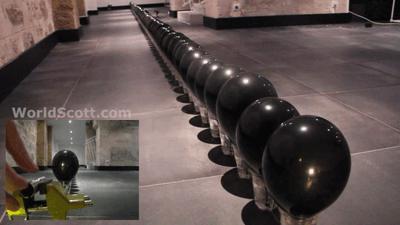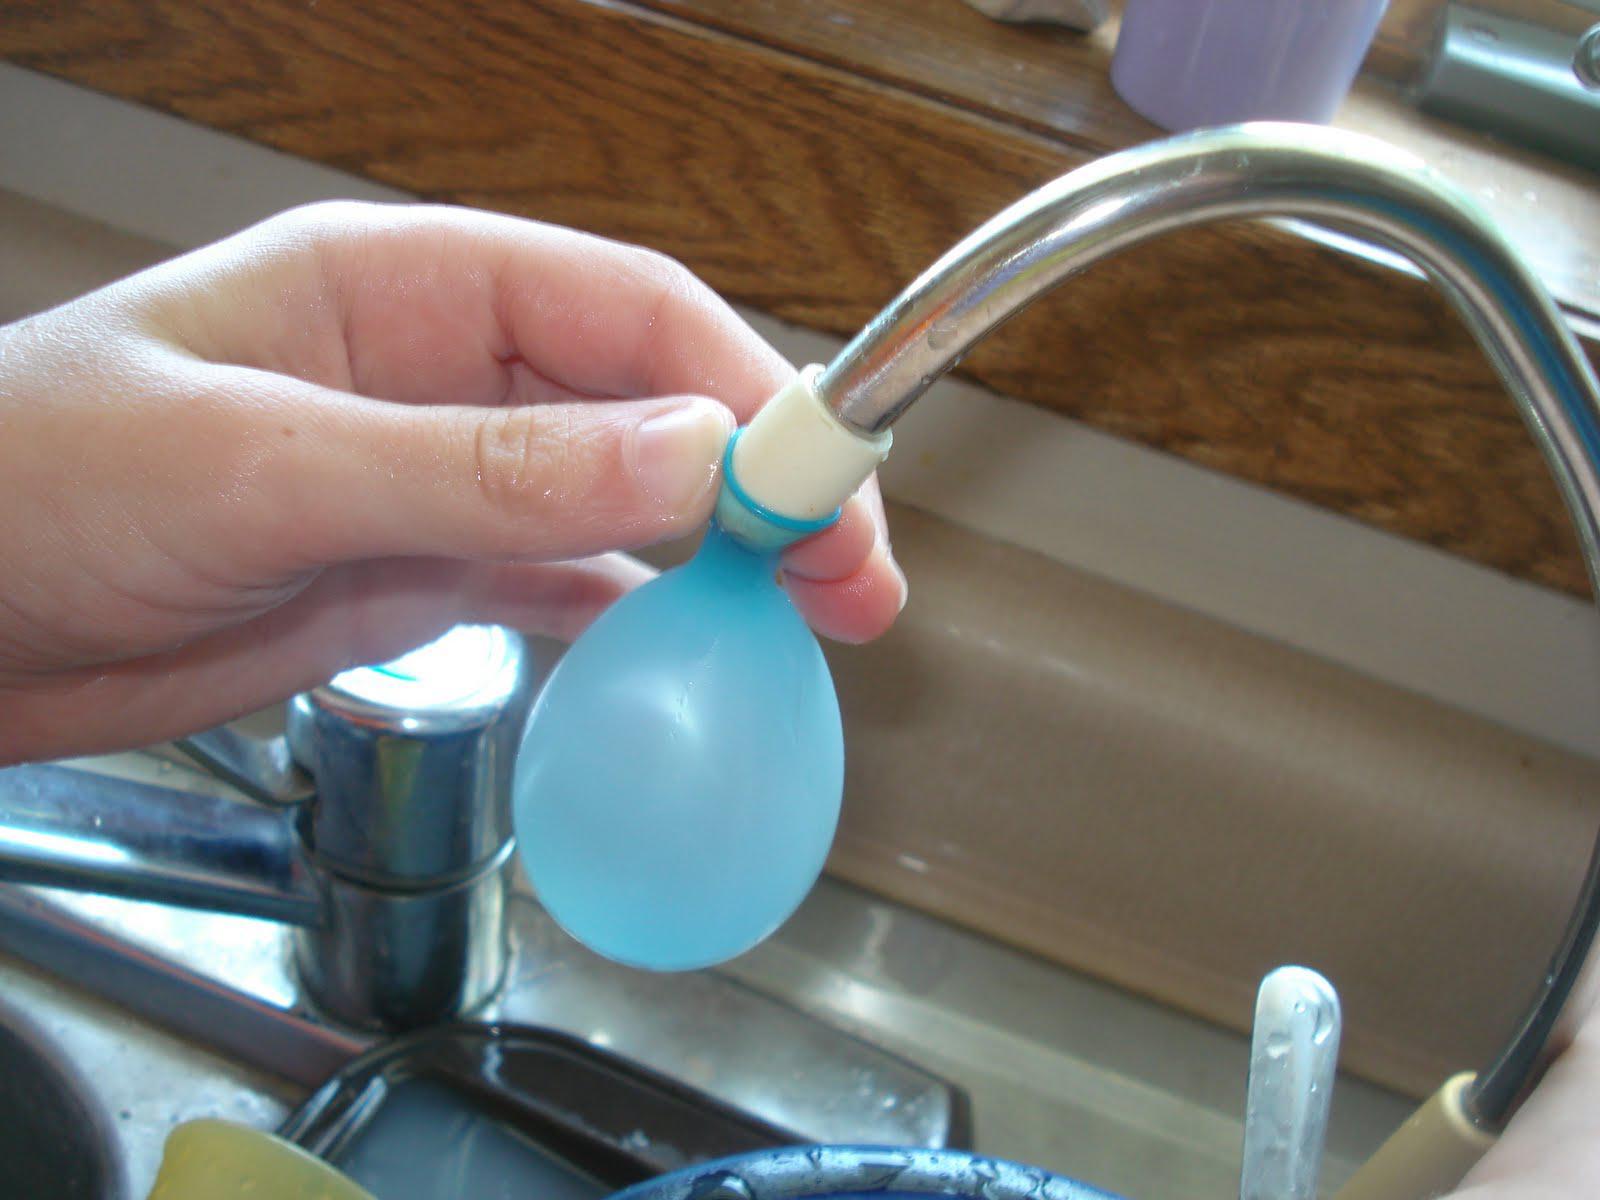The first image is the image on the left, the second image is the image on the right. For the images shown, is this caption "In at least one image there is a single balloon being filled from a water faucet." true? Answer yes or no. Yes. The first image is the image on the left, the second image is the image on the right. For the images displayed, is the sentence "A partially filled balloon is attached to a faucet." factually correct? Answer yes or no. Yes. 